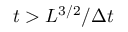Convert formula to latex. <formula><loc_0><loc_0><loc_500><loc_500>t > L ^ { 3 / 2 } / \Delta t</formula> 